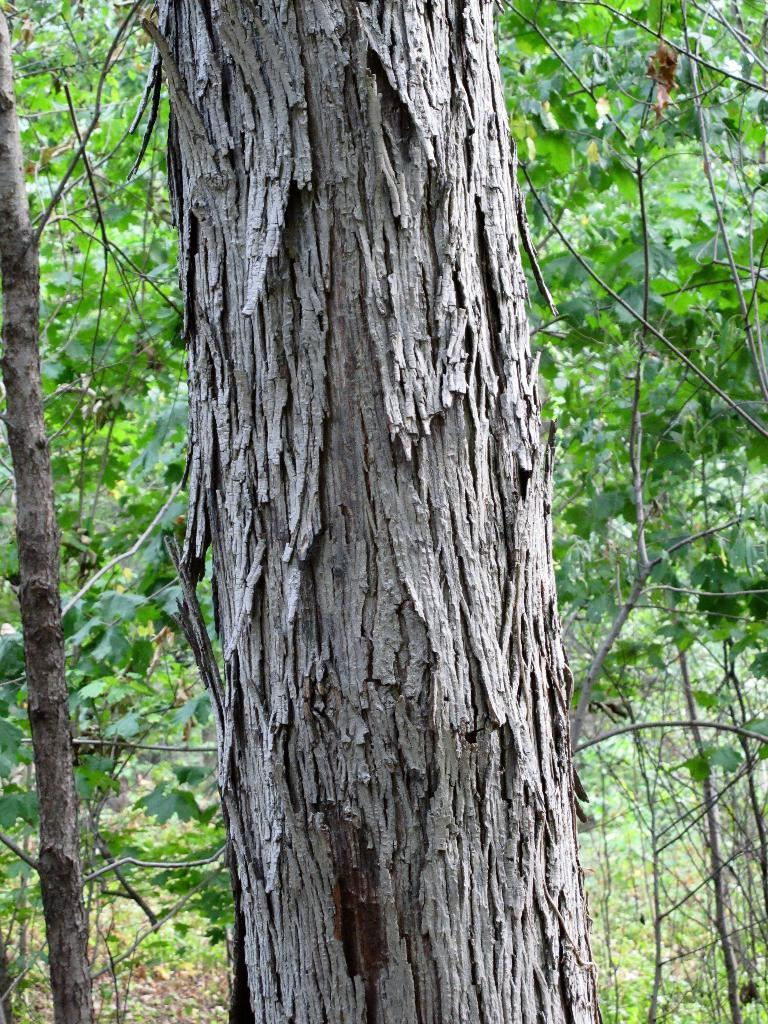What is the main subject in the front of the image? There is a tree trunk in the front of the image. What can be seen in the background of the image? There are trees in the background of the image. How many trains can be seen passing by the tree trunk in the image? There are no trains present in the image; it features a tree trunk and trees in the background. 